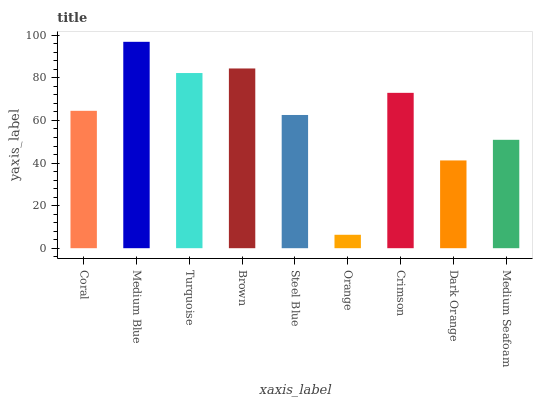Is Orange the minimum?
Answer yes or no. Yes. Is Medium Blue the maximum?
Answer yes or no. Yes. Is Turquoise the minimum?
Answer yes or no. No. Is Turquoise the maximum?
Answer yes or no. No. Is Medium Blue greater than Turquoise?
Answer yes or no. Yes. Is Turquoise less than Medium Blue?
Answer yes or no. Yes. Is Turquoise greater than Medium Blue?
Answer yes or no. No. Is Medium Blue less than Turquoise?
Answer yes or no. No. Is Coral the high median?
Answer yes or no. Yes. Is Coral the low median?
Answer yes or no. Yes. Is Steel Blue the high median?
Answer yes or no. No. Is Orange the low median?
Answer yes or no. No. 